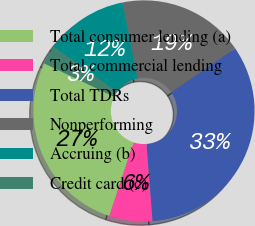<chart> <loc_0><loc_0><loc_500><loc_500><pie_chart><fcel>Total consumer lending (a)<fcel>Total commercial lending<fcel>Total TDRs<fcel>Nonperforming<fcel>Accruing (b)<fcel>Credit card (c)<nl><fcel>27.03%<fcel>6.31%<fcel>33.33%<fcel>18.53%<fcel>12.09%<fcel>2.72%<nl></chart> 